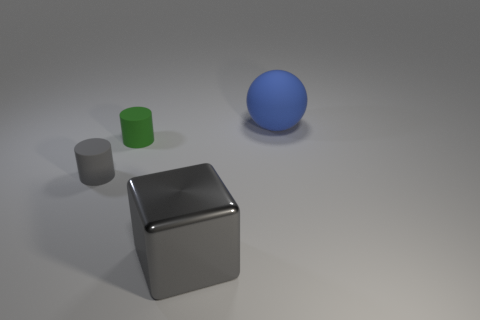Can you describe the lighting and setting the objects are placed in? The objects are set against a neutral, lightly textured background, and there is a soft shadow cast under each item. This suggests a single diffuse light source above the scene, creating soft-edged shadows. The setting seems to be an artificially lit studio or a controlled environment designed to minimize distractions and focus on the objects themselves. 